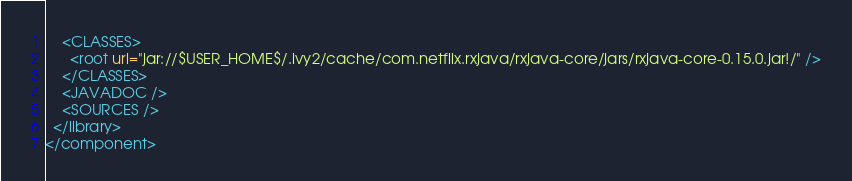Convert code to text. <code><loc_0><loc_0><loc_500><loc_500><_XML_>    <CLASSES>
      <root url="jar://$USER_HOME$/.ivy2/cache/com.netflix.rxjava/rxjava-core/jars/rxjava-core-0.15.0.jar!/" />
    </CLASSES>
    <JAVADOC />
    <SOURCES />
  </library>
</component></code> 